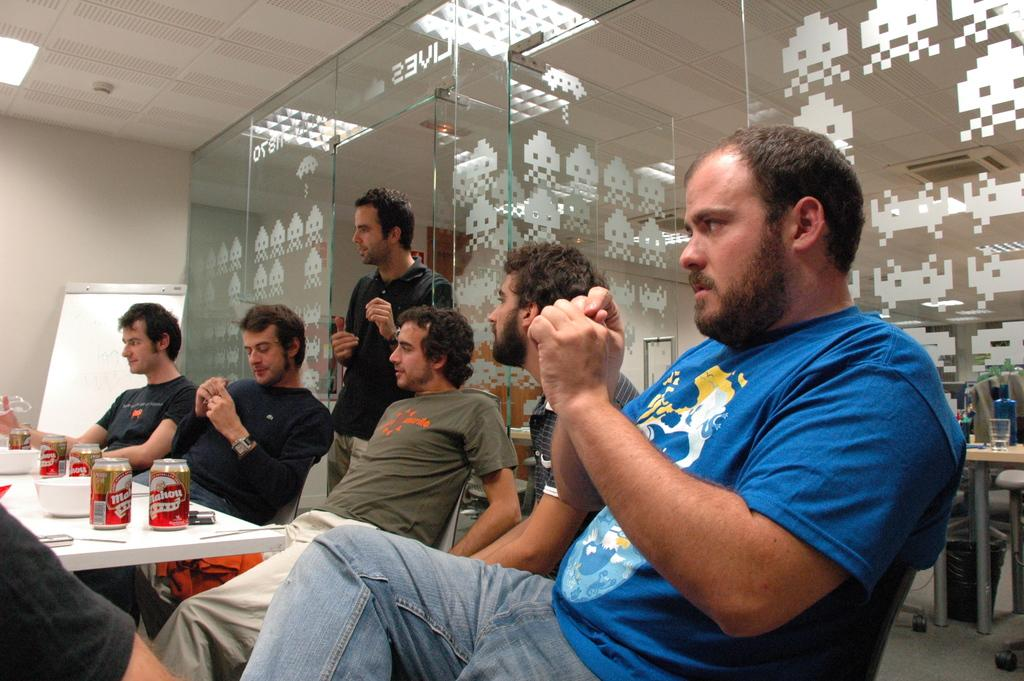How many people are in the image? There is a group of people in the image. What is the position of one person in the group? One person is standing. What is on the table in the image? There is a table in the image with a coke tin and bowls present. What can be seen in the background of the image? There is a wall and a board in the background of the image. What type of gold can be seen in the image? There is no gold present in the image. Is there a pet visible in the image? There is no pet visible in the image. 